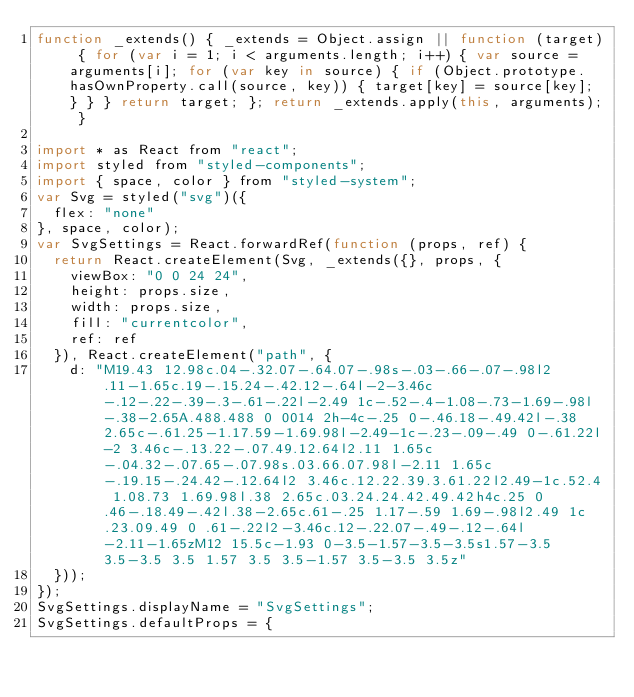Convert code to text. <code><loc_0><loc_0><loc_500><loc_500><_JavaScript_>function _extends() { _extends = Object.assign || function (target) { for (var i = 1; i < arguments.length; i++) { var source = arguments[i]; for (var key in source) { if (Object.prototype.hasOwnProperty.call(source, key)) { target[key] = source[key]; } } } return target; }; return _extends.apply(this, arguments); }

import * as React from "react";
import styled from "styled-components";
import { space, color } from "styled-system";
var Svg = styled("svg")({
  flex: "none"
}, space, color);
var SvgSettings = React.forwardRef(function (props, ref) {
  return React.createElement(Svg, _extends({}, props, {
    viewBox: "0 0 24 24",
    height: props.size,
    width: props.size,
    fill: "currentcolor",
    ref: ref
  }), React.createElement("path", {
    d: "M19.43 12.98c.04-.32.07-.64.07-.98s-.03-.66-.07-.98l2.11-1.65c.19-.15.24-.42.12-.64l-2-3.46c-.12-.22-.39-.3-.61-.22l-2.49 1c-.52-.4-1.08-.73-1.69-.98l-.38-2.65A.488.488 0 0014 2h-4c-.25 0-.46.18-.49.42l-.38 2.65c-.61.25-1.17.59-1.69.98l-2.49-1c-.23-.09-.49 0-.61.22l-2 3.46c-.13.22-.07.49.12.64l2.11 1.65c-.04.32-.07.65-.07.98s.03.66.07.98l-2.11 1.65c-.19.15-.24.42-.12.64l2 3.46c.12.22.39.3.61.22l2.49-1c.52.4 1.08.73 1.69.98l.38 2.65c.03.24.24.42.49.42h4c.25 0 .46-.18.49-.42l.38-2.65c.61-.25 1.17-.59 1.69-.98l2.49 1c.23.09.49 0 .61-.22l2-3.46c.12-.22.07-.49-.12-.64l-2.11-1.65zM12 15.5c-1.93 0-3.5-1.57-3.5-3.5s1.57-3.5 3.5-3.5 3.5 1.57 3.5 3.5-1.57 3.5-3.5 3.5z"
  }));
});
SvgSettings.displayName = "SvgSettings";
SvgSettings.defaultProps = {</code> 